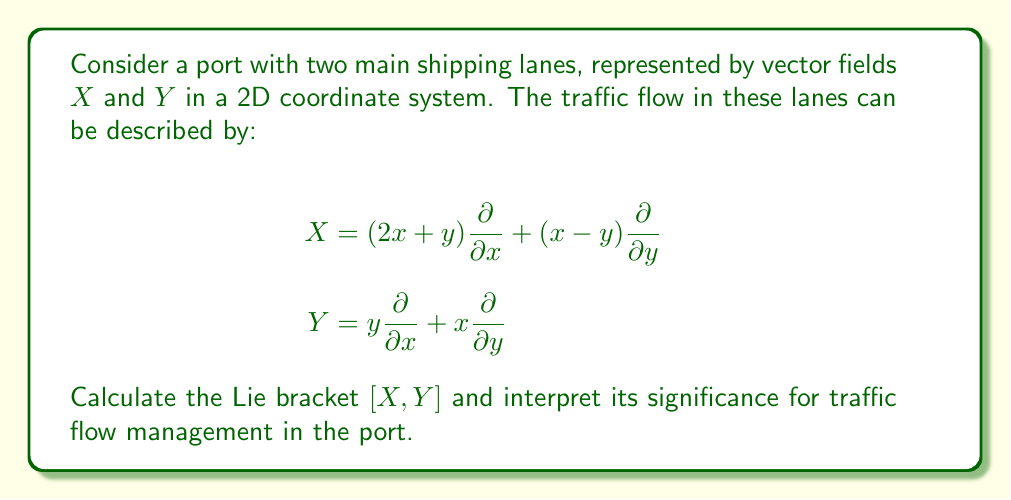What is the answer to this math problem? To solve this problem, we need to follow these steps:

1) Recall the formula for the Lie bracket of two vector fields $X$ and $Y$:

   $$[X,Y] = XY - YX$$

2) Expand $X$ and $Y$:
   
   $$X = (2x+y)\frac{\partial}{\partial x} + (x-y)\frac{\partial}{\partial y}$$
   $$Y = y\frac{\partial}{\partial x} + x\frac{\partial}{\partial y}$$

3) Calculate $XY$:
   
   $$XY = (2x+y)\frac{\partial}{\partial x}(y) + (x-y)\frac{\partial}{\partial y}(x) + (2x+y)\frac{\partial}{\partial x}(x) + (x-y)\frac{\partial}{\partial y}(y)$$
   $$= (2x+y)(1) + (x-y)(1) + (2x+y)(0) + (x-y)(1)$$
   $$= 2x+y+x-y+x-y = 3x-y$$

4) Calculate $YX$:
   
   $$YX = y\frac{\partial}{\partial x}(2x+y) + x\frac{\partial}{\partial y}(2x+y) + y\frac{\partial}{\partial x}(x-y) + x\frac{\partial}{\partial y}(x-y)$$
   $$= y(2) + x(1) + y(1) + x(-1) = 2y+x+y-x = 3y$$

5) Compute $[X,Y] = XY - YX$:
   
   $$[X,Y] = (3x-y) - (3y) = 3x-4y$$

6) Express the result as a vector field:
   
   $$[X,Y] = 3x\frac{\partial}{\partial x} - 4y\frac{\partial}{\partial y}$$

Interpretation: The Lie bracket $[X,Y]$ represents the net effect of alternating between the two traffic flows infinitesimally. A non-zero result indicates that the flows do not commute, meaning the order in which ships navigate these lanes matters. The specific form of $[X,Y]$ suggests that:

- There's a tendency for traffic to increase along the x-axis (3x term), potentially causing congestion.
- There's a stronger tendency for traffic to decrease along the y-axis (-4y term), possibly indicating a clearing effect.

This information can be crucial for traffic management, suggesting that coordinating the timing and sequencing of ships in these lanes could significantly impact overall port efficiency.
Answer: $$[X,Y] = 3x\frac{\partial}{\partial x} - 4y\frac{\partial}{\partial y}$$ 